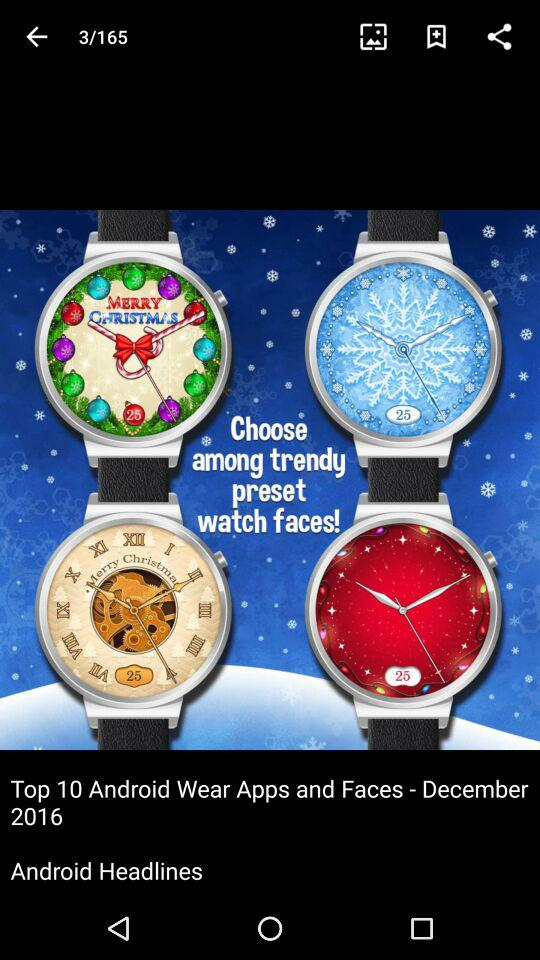On what image are we now? You are on image 3. 